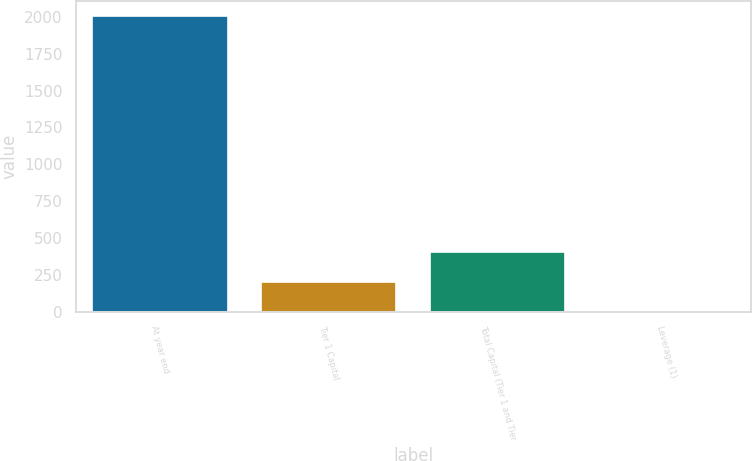Convert chart. <chart><loc_0><loc_0><loc_500><loc_500><bar_chart><fcel>At year end<fcel>Tier 1 Capital<fcel>Total Capital (Tier 1 and Tier<fcel>Leverage (1)<nl><fcel>2007<fcel>204.33<fcel>404.63<fcel>4.03<nl></chart> 